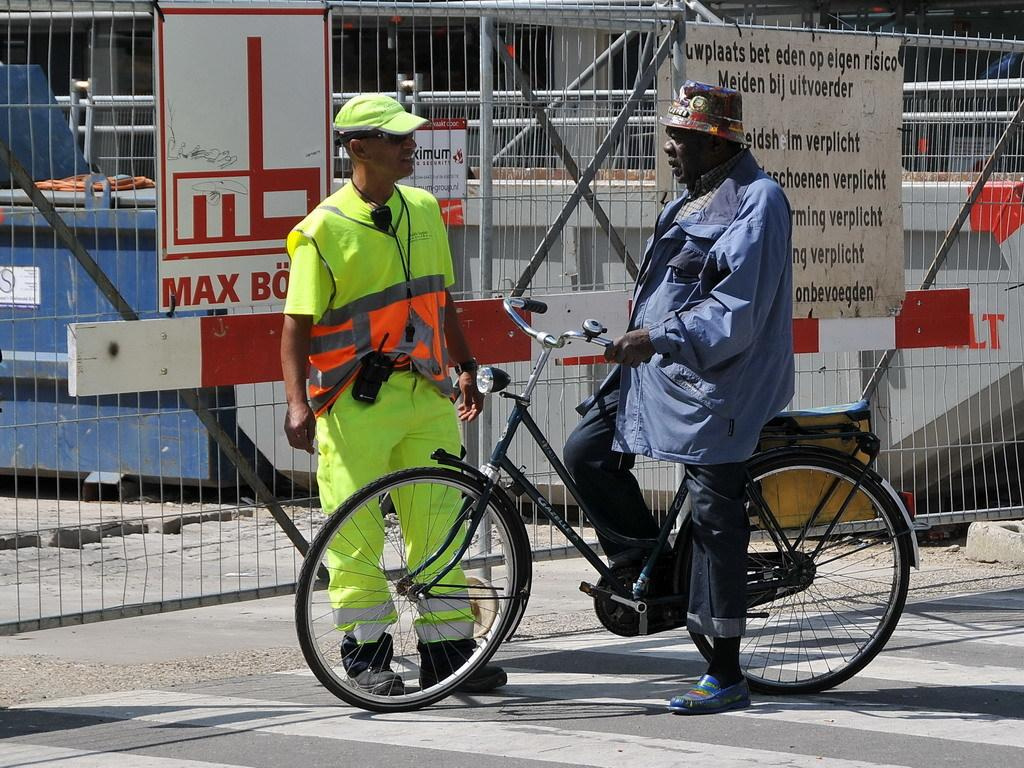How many people are in the image? There are two men in the image. What are the men doing in the image? One of the men is standing on the road, and the other man is on a bicycle. What safety precaution is the man on the bicycle taking? The man on the bicycle is wearing a helmet. What can be seen in the background of the image? There is a fence and a board in the background of the image. What type of hen can be seen sitting on the fence in the image? There is no hen present in the image; it only features two men, one standing on the road and the other on a bicycle. 